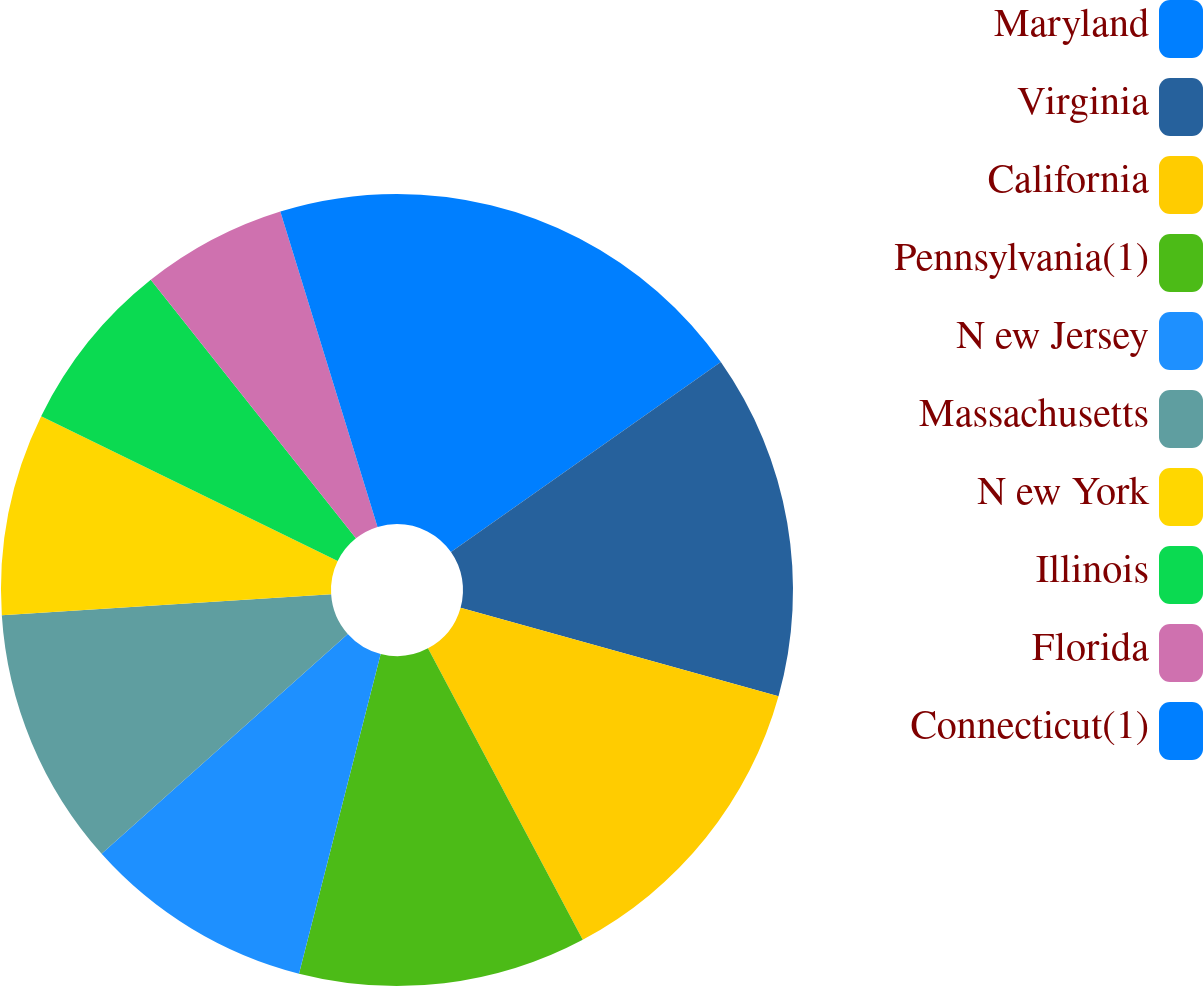Convert chart. <chart><loc_0><loc_0><loc_500><loc_500><pie_chart><fcel>Maryland<fcel>Virginia<fcel>California<fcel>Pennsylvania(1)<fcel>N ew Jersey<fcel>Massachusetts<fcel>N ew York<fcel>Illinois<fcel>Florida<fcel>Connecticut(1)<nl><fcel>15.24%<fcel>14.08%<fcel>12.91%<fcel>11.75%<fcel>9.42%<fcel>10.58%<fcel>8.25%<fcel>7.09%<fcel>5.92%<fcel>4.76%<nl></chart> 